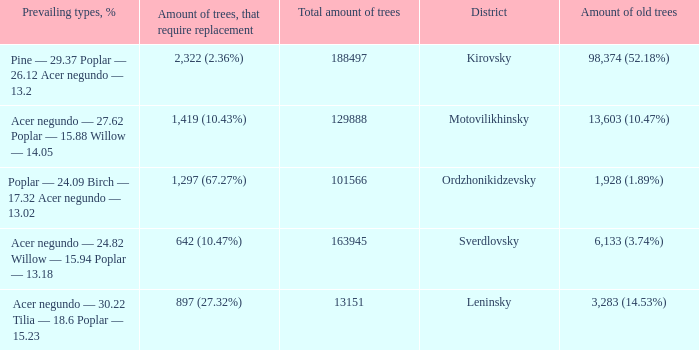What is the district when prevailing types, % is acer negundo — 30.22 tilia — 18.6 poplar — 15.23? Leninsky. 